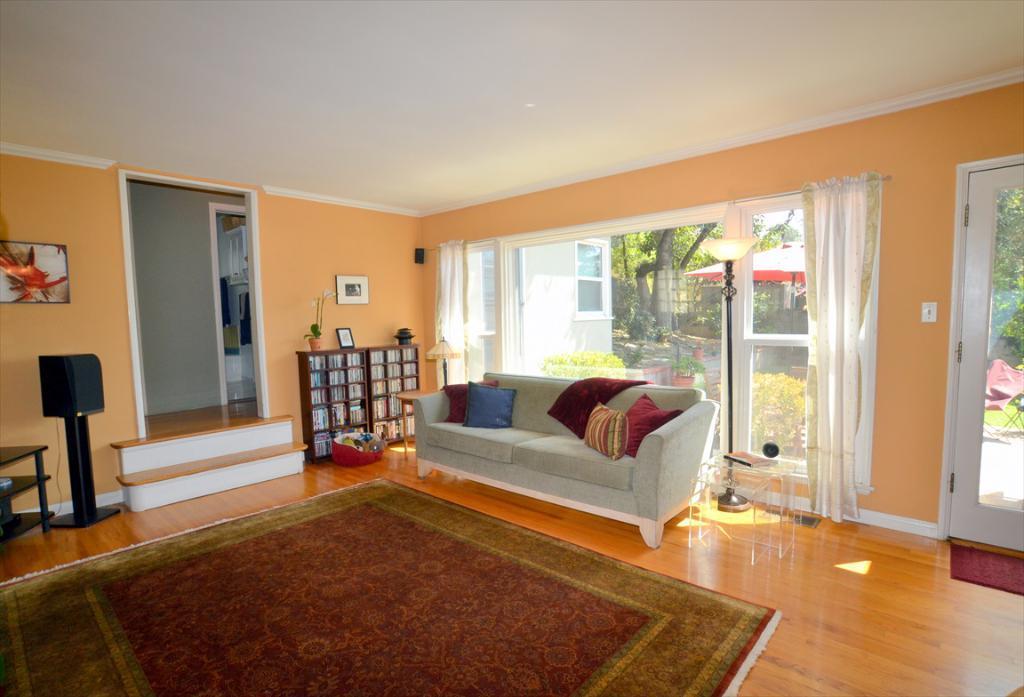How would you summarize this image in a sentence or two? This is a house. Here we can see a door and windows. These are curtains. This is a sofa with cushions on it. This is a floor and a carpet. This is a doormat. Here we can see a rack and on the rack we can see a house plant and a photo frame. There is a photo frame over a wall. This is a stair. This is other room. This is a table. 